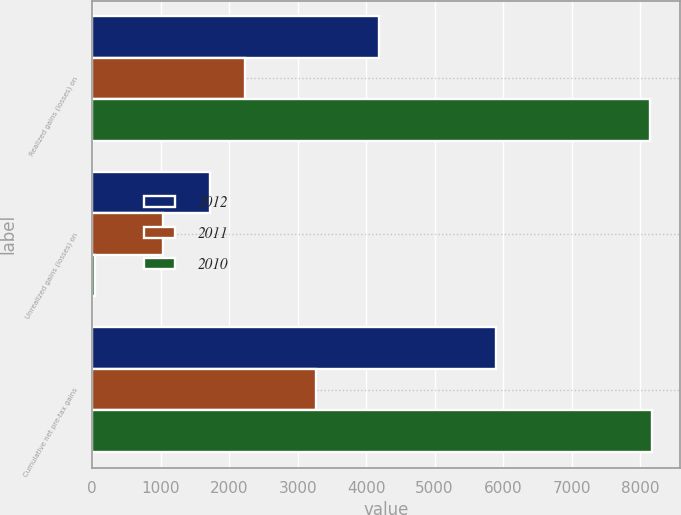Convert chart. <chart><loc_0><loc_0><loc_500><loc_500><stacked_bar_chart><ecel><fcel>Realized gains (losses) on<fcel>Unrealized gains (losses) on<fcel>Cumulative net pre-tax gains<nl><fcel>2012<fcel>4186<fcel>1716<fcel>5902<nl><fcel>2011<fcel>2233<fcel>1035<fcel>3268<nl><fcel>2010<fcel>8138<fcel>39<fcel>8177<nl></chart> 